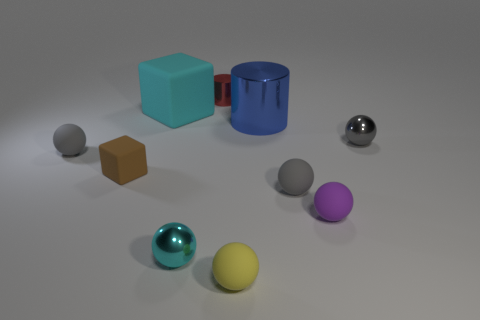Subtract all cyan balls. How many balls are left? 5 Subtract all cyan spheres. How many spheres are left? 5 Subtract all purple blocks. How many gray balls are left? 3 Subtract all spheres. How many objects are left? 4 Subtract all cyan blocks. Subtract all gray balls. How many blocks are left? 1 Subtract all yellow shiny balls. Subtract all cyan matte blocks. How many objects are left? 9 Add 8 blue cylinders. How many blue cylinders are left? 9 Add 7 small cyan rubber balls. How many small cyan rubber balls exist? 7 Subtract 0 gray blocks. How many objects are left? 10 